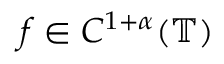<formula> <loc_0><loc_0><loc_500><loc_500>f \in C ^ { 1 + \alpha } ( \mathbb { T } )</formula> 